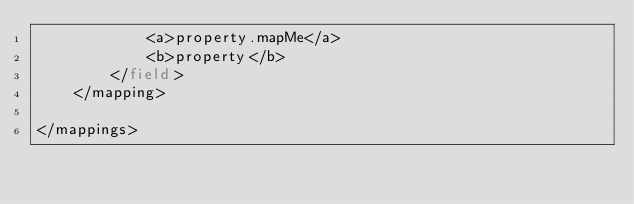<code> <loc_0><loc_0><loc_500><loc_500><_XML_>            <a>property.mapMe</a>
            <b>property</b>
        </field>
    </mapping>

</mappings>

</code> 